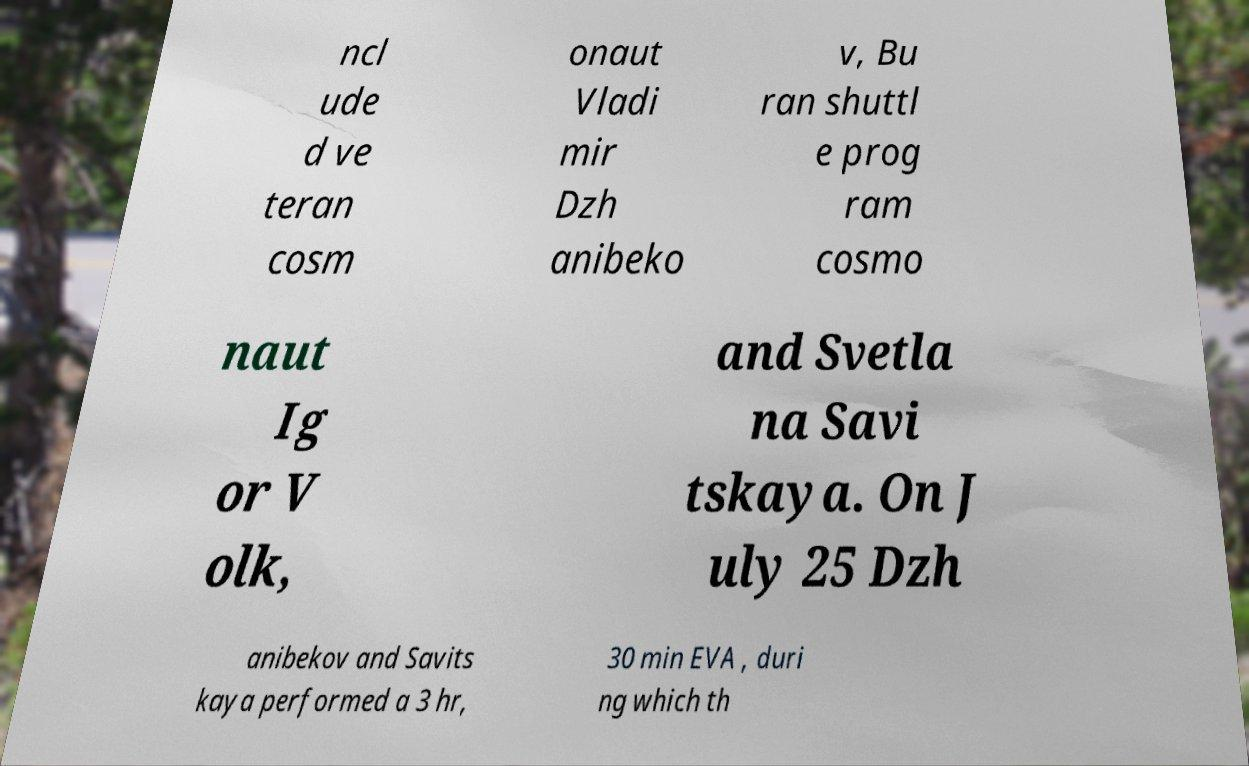Please read and relay the text visible in this image. What does it say? ncl ude d ve teran cosm onaut Vladi mir Dzh anibeko v, Bu ran shuttl e prog ram cosmo naut Ig or V olk, and Svetla na Savi tskaya. On J uly 25 Dzh anibekov and Savits kaya performed a 3 hr, 30 min EVA , duri ng which th 